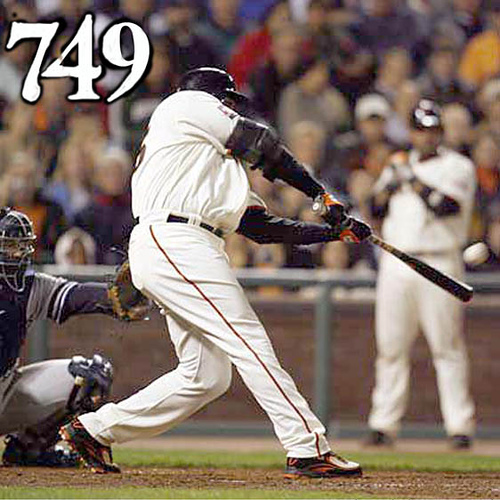<image>Who is the batter? I don't know who the batter is. It could be David Ortiz, James Johnson, or Sammy Sosa. Who is the batter? I don't know who is the batter. It can be David Ortiz, chet, James Johnson, 749, Barry Bonds or Sammy Sosa. 